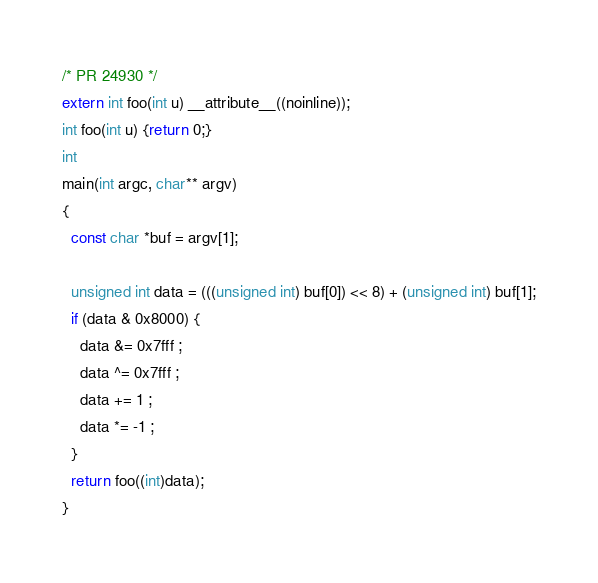<code> <loc_0><loc_0><loc_500><loc_500><_C_>/* PR 24930 */
extern int foo(int u) __attribute__((noinline));
int foo(int u) {return 0;}
int
main(int argc, char** argv)
{
  const char *buf = argv[1];
  
  unsigned int data = (((unsigned int) buf[0]) << 8) + (unsigned int) buf[1];
  if (data & 0x8000) {
    data &= 0x7fff ;
    data ^= 0x7fff ;
    data += 1 ;
    data *= -1 ;
  }
  return foo((int)data);
}
</code> 